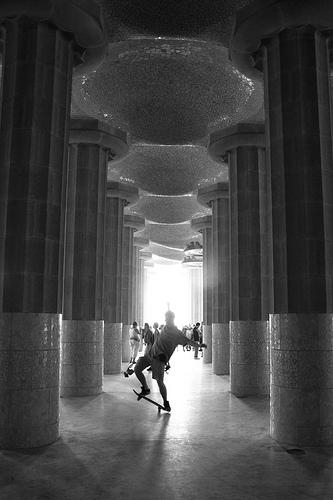Provide a brief description of how the people in the background are dressed. There is a woman in a white outfit, a man in a black shirt, and several other people dressed in various clothing. In a single sentence, talk about the surroundings of the skateboarder in the picture. The skateboarder is in a granite-floored building with concave ceilings, columns, and many people in the background. Provide a brief overview of the image, focusing on the skateboarder, building, and other people present. The image features a skateboarder performing tricks in a granite-floored building with concave ceilings and columns, surrounded by several people in the background. Briefly describe the clothing of the skateboarder and a woman in the background. The skateboarder is wearing a shirt, shorts, and black shoes, while the woman in the background is dressed in white. Describe the building that the skateboarder is in and mention any distinguishing features. The skateboarder is in a stone building with granite floors, concave ceilings, and columns made of cement with round poles. What is the primary action taking place in the image? A man is performing skateboarding tricks with his extended arms and wearing shorts in a building. What can you say about the appearance of the skateboarder? The skateboarder is wearing a shirt, shorts and black shoes with his arms extended while performing tricks. Identify the focus of the image and how the background elements relate to the main subject. The focus is on the skateboarder performing tricks, as the background elements, including the people and building, set the context. What is the primary activity of the man in the image, and where are the people he is with located? The man is skateboarding, and the people accompanying him are located in the background behind him. What are the conditions outside the building, and how does that affect the image's atmosphere? It is sunny outside the building, with light reflecting on the floor and creating an illuminated atmosphere. 